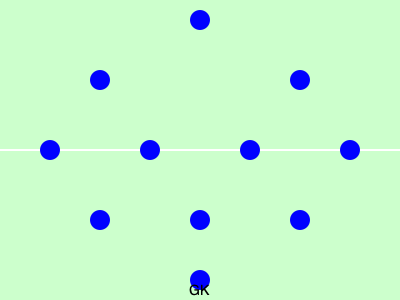Which popular formation is illustrated in this diagram of the Ukrainian national team's setup? To identify the formation, we need to count the number of players in each line from back to front:

1. There is 1 goalkeeper (GK) at the back.
2. In the defensive line, there are 3 players.
3. In the midfield, we can see 4 players.
4. In the attack, there are 3 players.

Counting from back to front (excluding the goalkeeper), we have 3-4-3.

This formation is known as the 3-4-3 formation, which has been used by the Ukrainian national team in recent years, especially under former coach Andriy Shevchenko.

The 3-4-3 formation is characterized by:
- A back three of defenders
- Four midfielders (typically two central and two wide)
- Three forwards (typically one central striker and two wide forwards)

This formation allows for a balance between defensive stability and attacking prowess, which suits the Ukrainian team's style of play.
Answer: 3-4-3 